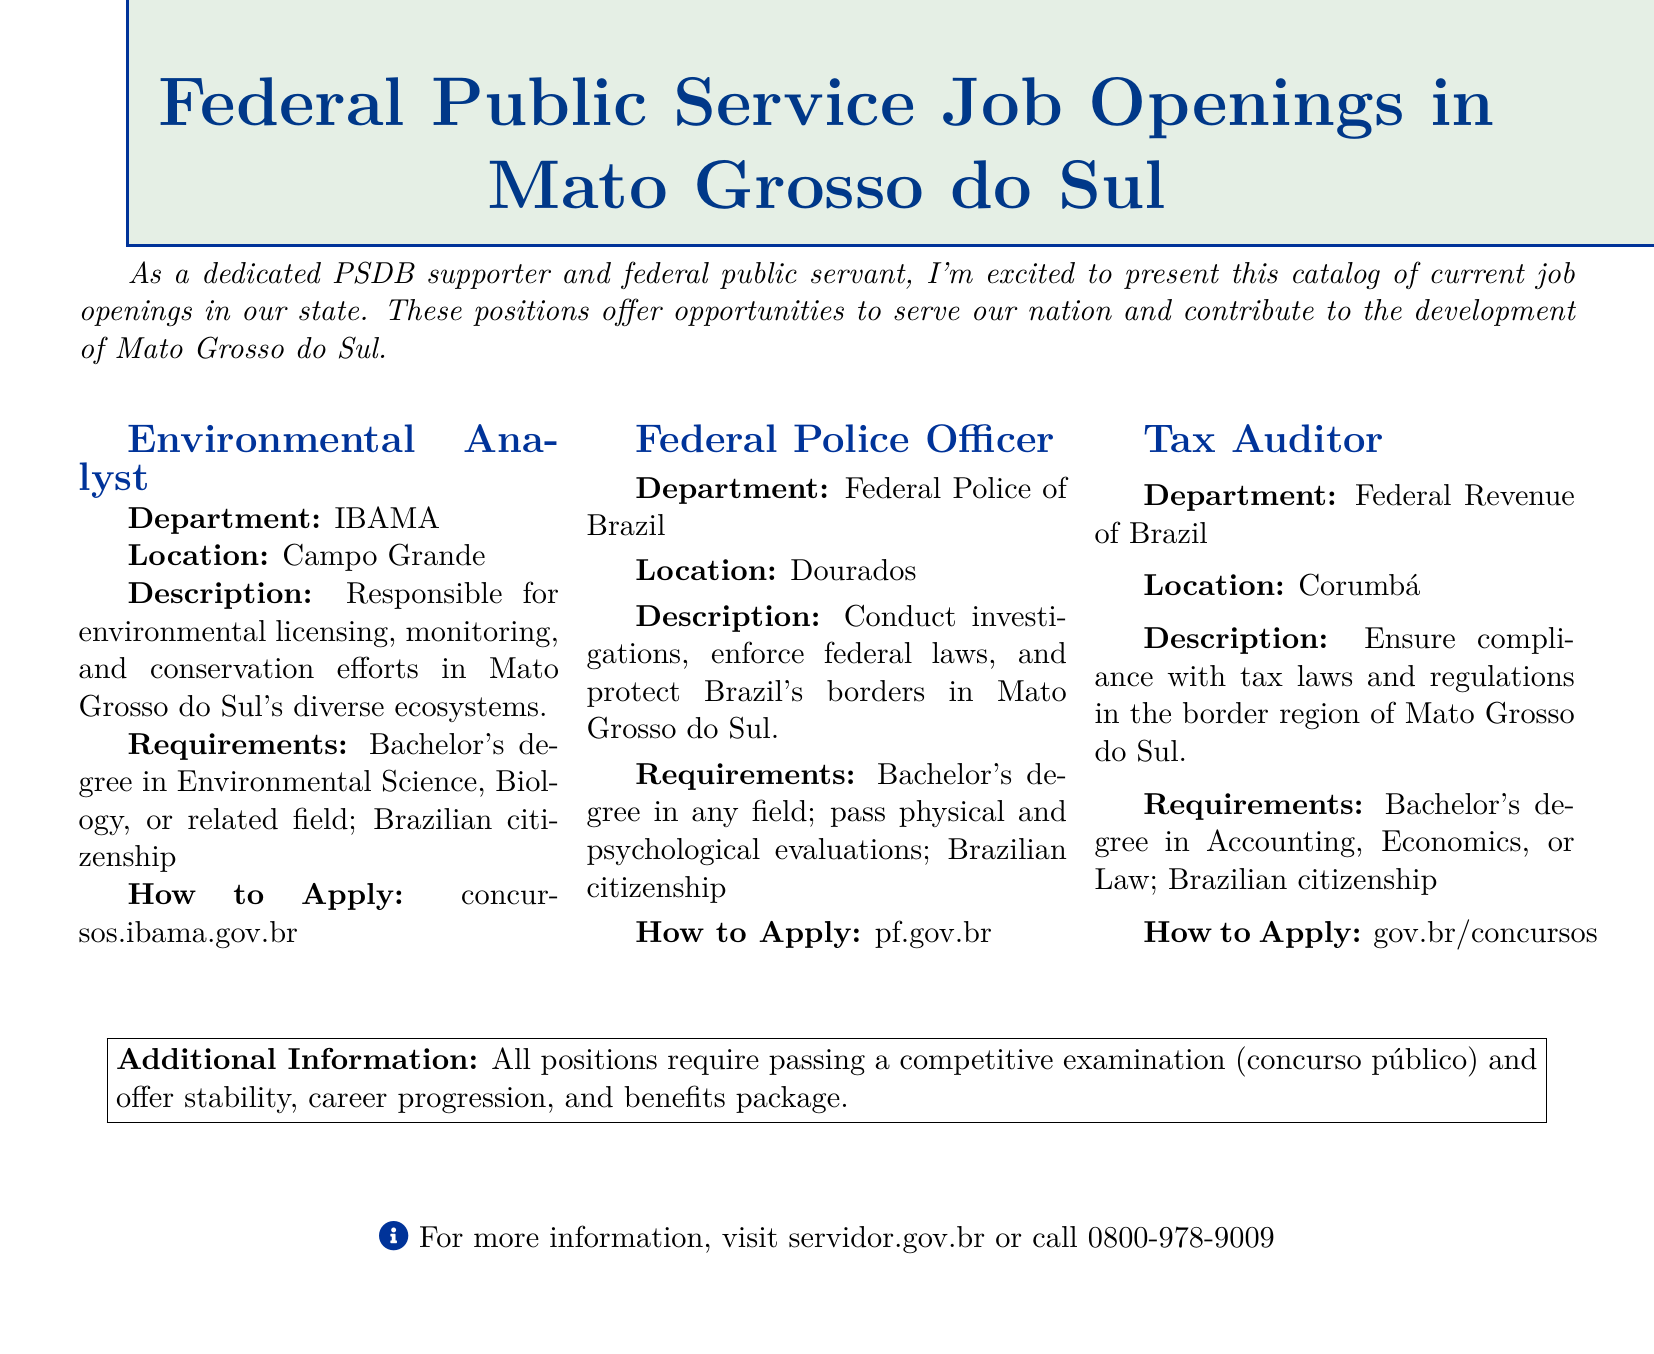what is the location of the Federal Police Officer position? The Federal Police Officer position is located in Dourados, as listed in the document.
Answer: Dourados what department is hiring for the Tax Auditor position? The Tax Auditor position is being offered by the Federal Revenue of Brazil department, mentioned in the document.
Answer: Federal Revenue of Brazil what degree is required for the Environmental Analyst position? The Environmental Analyst position requires a Bachelor's degree in Environmental Science, Biology, or a related field, as stated in the document.
Answer: Bachelor's degree in Environmental Science, Biology, or related field how many job openings are listed in this catalog? The catalog presents three job openings listed for various positions in the Mato Grosso do Sul region.
Answer: Three what is the application website for the Tax Auditor position? The document specifies gov.br/concursos as the application website for the Tax Auditor position.
Answer: gov.br/concursos what common requirement is needed for all positions? All positions require Brazilian citizenship, as indicated in the document.
Answer: Brazilian citizenship what benefits are mentioned for the job positions? The document states that the job positions offer stability, career progression, and a benefits package, summarizing the advantages available.
Answer: Stability, career progression, and benefits package which position requires passing physical and psychological evaluations? The Federal Police Officer position requires candidates to pass physical and psychological evaluations, as described in the document.
Answer: Federal Police Officer 